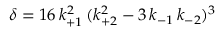<formula> <loc_0><loc_0><loc_500><loc_500>\delta = 1 6 \, k _ { + 1 } ^ { 2 } \, ( k _ { + 2 } ^ { 2 } - 3 \, k _ { - 1 } \, k _ { - 2 } ) ^ { 3 }</formula> 